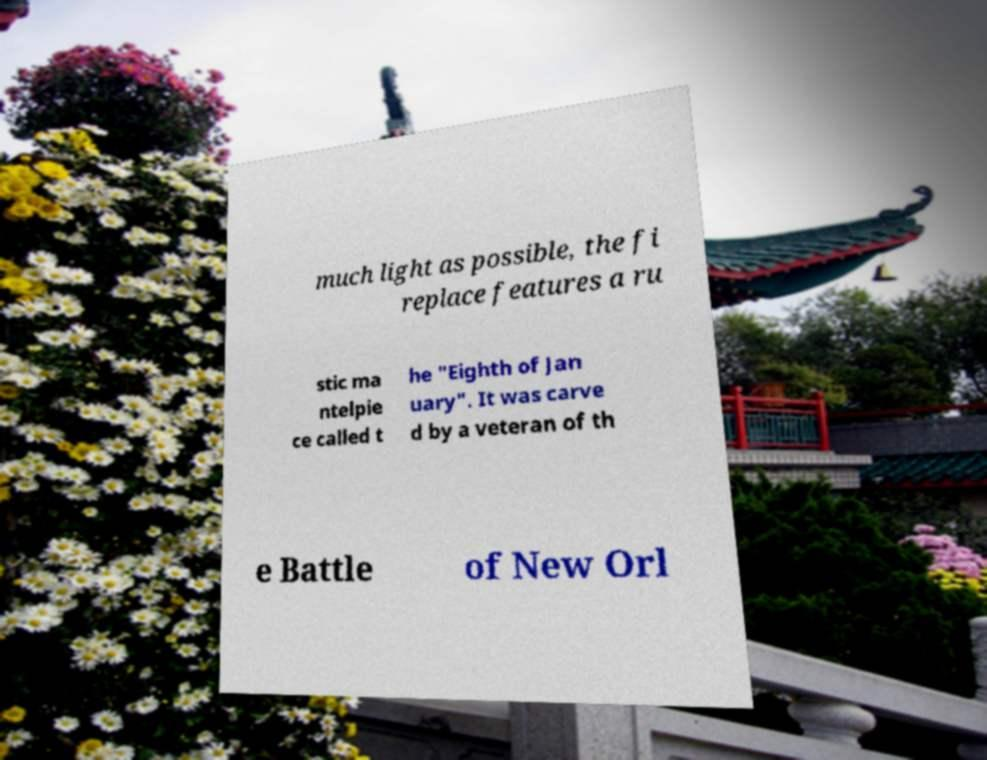There's text embedded in this image that I need extracted. Can you transcribe it verbatim? much light as possible, the fi replace features a ru stic ma ntelpie ce called t he "Eighth of Jan uary". It was carve d by a veteran of th e Battle of New Orl 